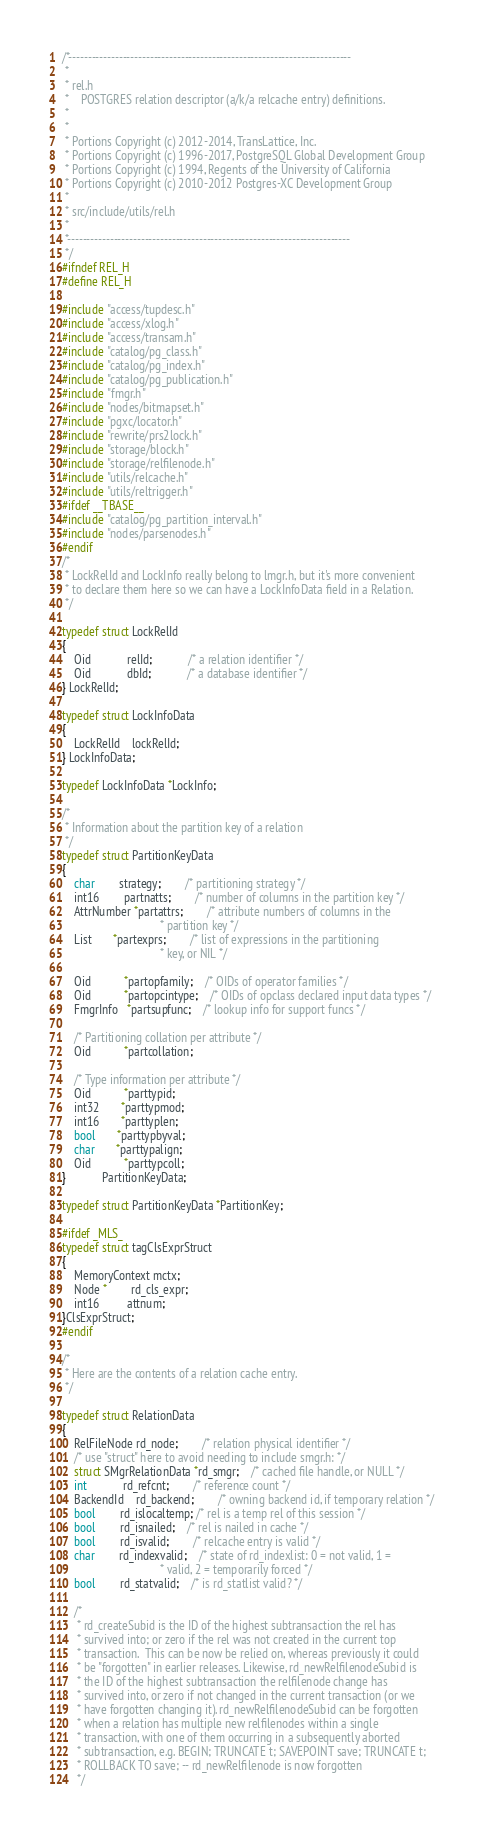<code> <loc_0><loc_0><loc_500><loc_500><_C_>/*-------------------------------------------------------------------------
 *
 * rel.h
 *	  POSTGRES relation descriptor (a/k/a relcache entry) definitions.
 *
 *
 * Portions Copyright (c) 2012-2014, TransLattice, Inc.
 * Portions Copyright (c) 1996-2017, PostgreSQL Global Development Group
 * Portions Copyright (c) 1994, Regents of the University of California
 * Portions Copyright (c) 2010-2012 Postgres-XC Development Group
 *
 * src/include/utils/rel.h
 *
 *-------------------------------------------------------------------------
 */
#ifndef REL_H
#define REL_H

#include "access/tupdesc.h"
#include "access/xlog.h"
#include "access/transam.h"
#include "catalog/pg_class.h"
#include "catalog/pg_index.h"
#include "catalog/pg_publication.h"
#include "fmgr.h"
#include "nodes/bitmapset.h"
#include "pgxc/locator.h"
#include "rewrite/prs2lock.h"
#include "storage/block.h"
#include "storage/relfilenode.h"
#include "utils/relcache.h"
#include "utils/reltrigger.h"
#ifdef __TBASE__
#include "catalog/pg_partition_interval.h"
#include "nodes/parsenodes.h"
#endif
/*
 * LockRelId and LockInfo really belong to lmgr.h, but it's more convenient
 * to declare them here so we can have a LockInfoData field in a Relation.
 */

typedef struct LockRelId
{
	Oid			relId;			/* a relation identifier */
	Oid			dbId;			/* a database identifier */
} LockRelId;

typedef struct LockInfoData
{
	LockRelId	lockRelId;
} LockInfoData;

typedef LockInfoData *LockInfo;

/*
 * Information about the partition key of a relation
 */
typedef struct PartitionKeyData
{
	char		strategy;		/* partitioning strategy */
	int16		partnatts;		/* number of columns in the partition key */
	AttrNumber *partattrs;		/* attribute numbers of columns in the
								 * partition key */
	List	   *partexprs;		/* list of expressions in the partitioning
								 * key, or NIL */

	Oid		   *partopfamily;	/* OIDs of operator families */
	Oid		   *partopcintype;	/* OIDs of opclass declared input data types */
	FmgrInfo   *partsupfunc;	/* lookup info for support funcs */

	/* Partitioning collation per attribute */
	Oid		   *partcollation;

	/* Type information per attribute */
	Oid		   *parttypid;
	int32	   *parttypmod;
	int16	   *parttyplen;
	bool	   *parttypbyval;
	char	   *parttypalign;
	Oid		   *parttypcoll;
}			PartitionKeyData;

typedef struct PartitionKeyData *PartitionKey;

#ifdef _MLS_
typedef struct tagClsExprStruct
{
    MemoryContext mctx;
    Node *        rd_cls_expr;
    int16         attnum;
}ClsExprStruct;
#endif

/*
 * Here are the contents of a relation cache entry.
 */

typedef struct RelationData
{
	RelFileNode rd_node;		/* relation physical identifier */
	/* use "struct" here to avoid needing to include smgr.h: */
	struct SMgrRelationData *rd_smgr;	/* cached file handle, or NULL */
	int			rd_refcnt;		/* reference count */
	BackendId	rd_backend;		/* owning backend id, if temporary relation */
	bool		rd_islocaltemp; /* rel is a temp rel of this session */
	bool		rd_isnailed;	/* rel is nailed in cache */
	bool		rd_isvalid;		/* relcache entry is valid */
	char		rd_indexvalid;	/* state of rd_indexlist: 0 = not valid, 1 =
								 * valid, 2 = temporarily forced */
	bool		rd_statvalid;	/* is rd_statlist valid? */

	/*
	 * rd_createSubid is the ID of the highest subtransaction the rel has
	 * survived into; or zero if the rel was not created in the current top
	 * transaction.  This can be now be relied on, whereas previously it could
	 * be "forgotten" in earlier releases. Likewise, rd_newRelfilenodeSubid is
	 * the ID of the highest subtransaction the relfilenode change has
	 * survived into, or zero if not changed in the current transaction (or we
	 * have forgotten changing it). rd_newRelfilenodeSubid can be forgotten
	 * when a relation has multiple new relfilenodes within a single
	 * transaction, with one of them occurring in a subsequently aborted
	 * subtransaction, e.g. BEGIN; TRUNCATE t; SAVEPOINT save; TRUNCATE t;
	 * ROLLBACK TO save; -- rd_newRelfilenode is now forgotten
	 */</code> 